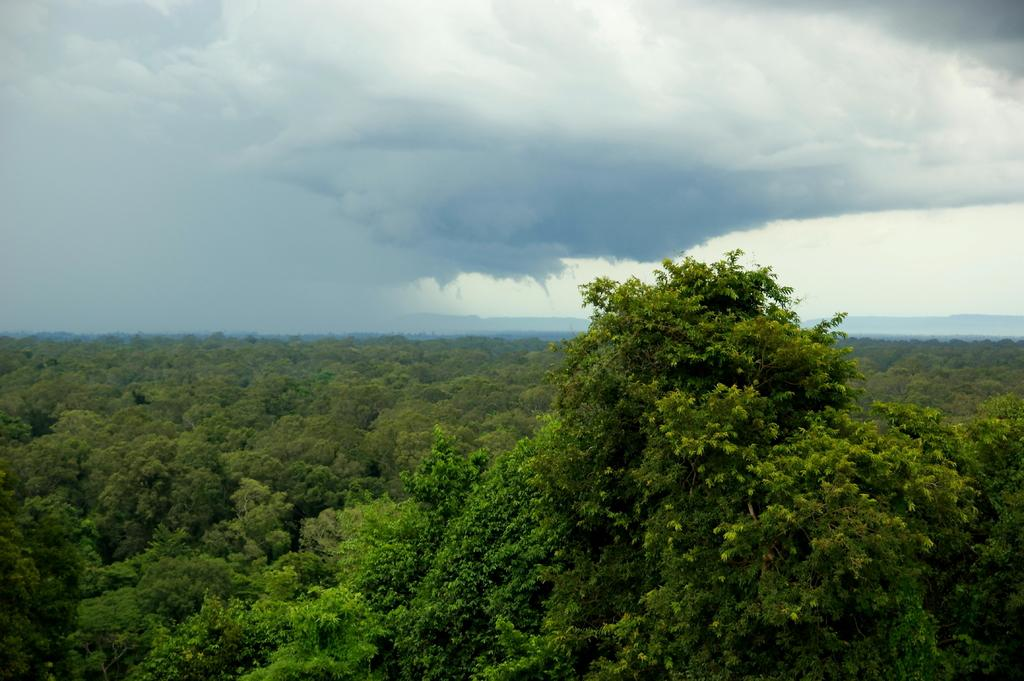What type of view is shown in the image? The image is an aerial view. What natural elements can be seen from above? There are trees visible in the image. What is visible in the sky in the image? Clouds are present in the sky in the image. What type of flowers can be seen growing in harmony with the trees in the image? There are no flowers visible in the image; only trees are present. 